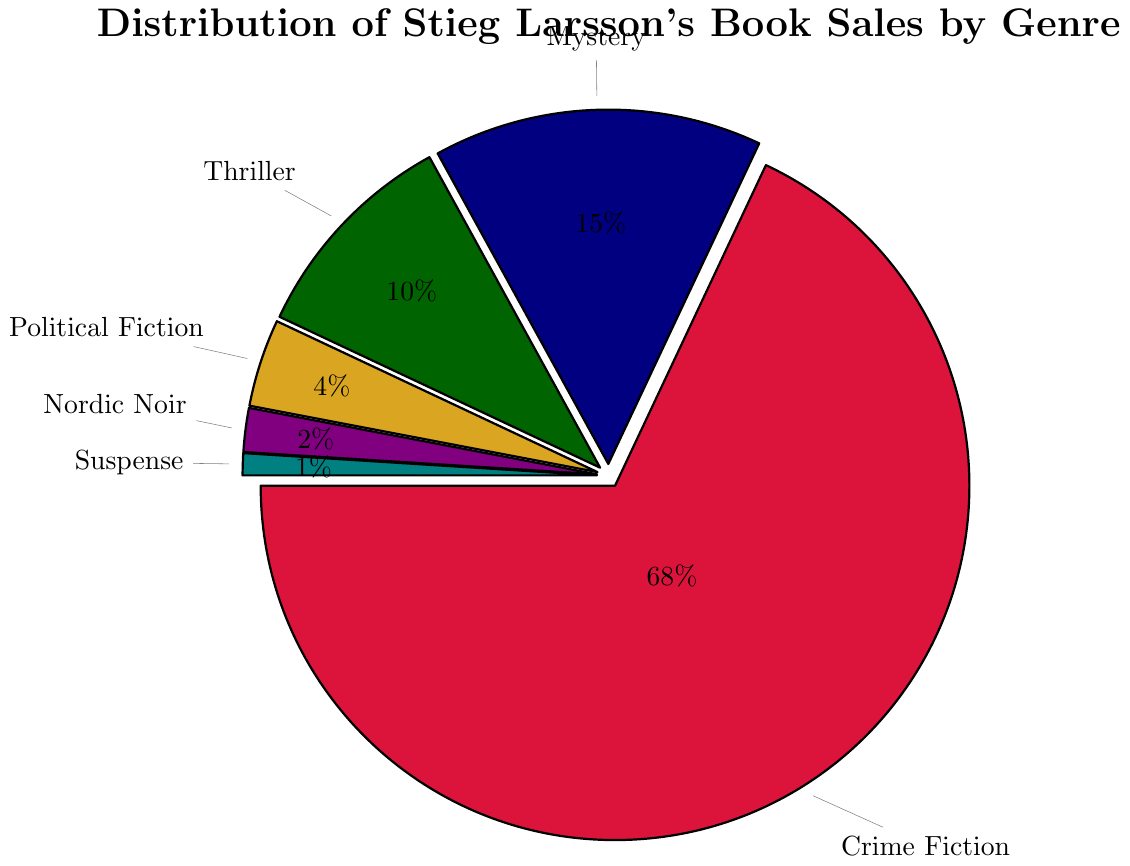What genre has the highest percentage of Stieg Larsson's book sales? The pie chart shows the distribution of book sales across various genres. Crime Fiction has the largest portion of the pie.
Answer: Crime Fiction What is the combined percentage of sales for Mystery and Thriller genres? From the pie chart, Mystery accounts for 15% and Thriller accounts for 10%. Adding these together: 15% + 10% = 25%
Answer: 25% Which genre has the smallest portion of sales? The pie chart shows that Suspense has the smallest portion of sales at 1%.
Answer: Suspense How much more is the percentage of Crime Fiction sales compared to Political Fiction sales? The percentage of Crime Fiction sales is 68%, and Political Fiction sales are 4%. Subtracting these gives: 68% - 4% = 64%
Answer: 64% What percentage of Stieg Larsson's book sales come from genres other than Crime Fiction? The total percentage for all genres is 100%. Subtracting the percentage of Crime Fiction sales: 100% - 68% = 32%
Answer: 32% Identify the colors used to represent Thriller and Nordic Noir genres in the chart. Thriller is shown in dark green, and Nordic Noir is shown in purple.
Answer: dark green and purple How does the percentage of Mystery sales compare to the percentage of Suspense sales? The percentage of Mystery sales is 15%, while Suspense sales are at 1%. Mystery sales are substantially higher.
Answer: Mystery sales are higher If the total number of books sold is 1 million, how many books were Suspense genre? Given Suspense accounts for 1%, we calculate 1% of 1 million: 1% of 1,000,000 = 0.01 * 1,000,000 = 10,000
Answer: 10,000 What would be the percentage if the sales of Thriller and Mystery genres were combined into a single genre? The percentage of Mystery is 15% and the percentage of Thriller is 10%. Adding these together: 15% + 10% = 25%
Answer: 25% Which genre has a percentage twice as much as Nordic Noir? Nordic Noir has a percentage of 2%. The genre with twice this percentage is 4%, which is Political Fiction.
Answer: Political Fiction 